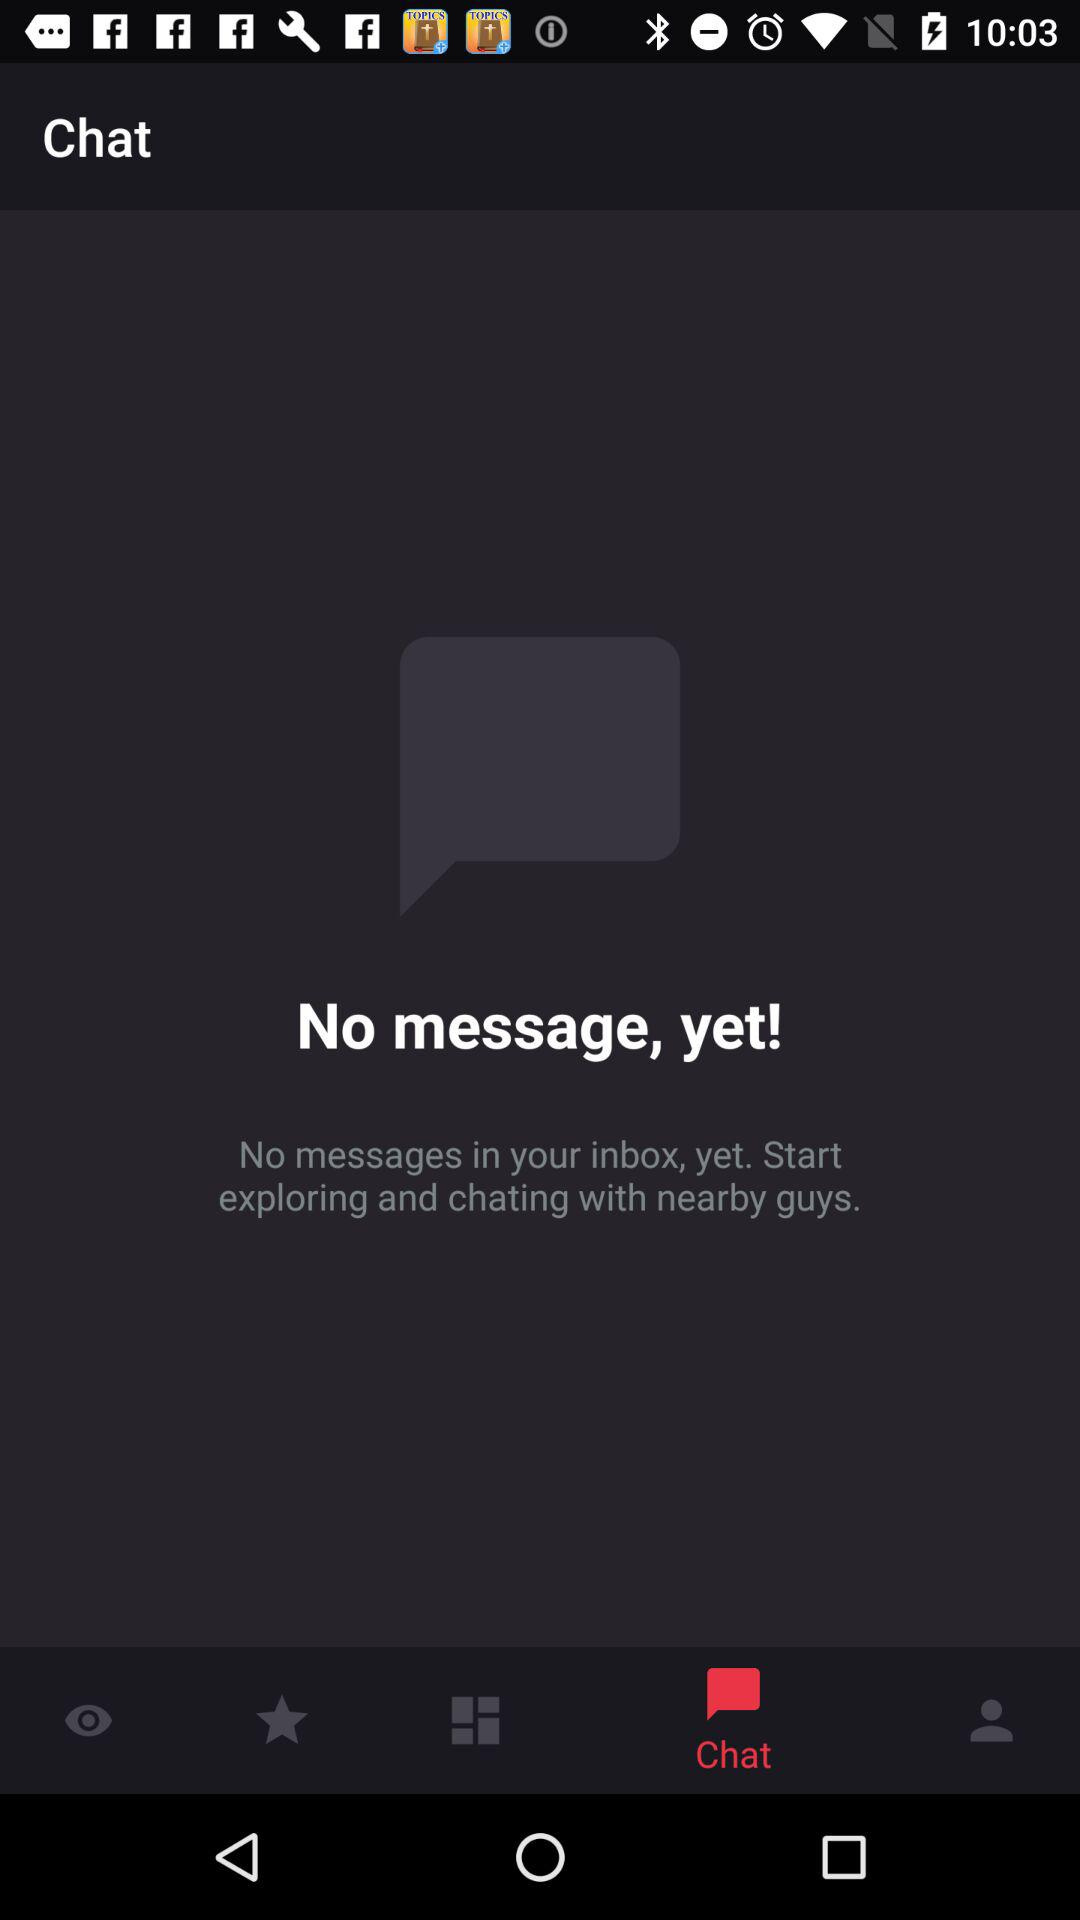What tab is selected? The selected tab is "Chat". 